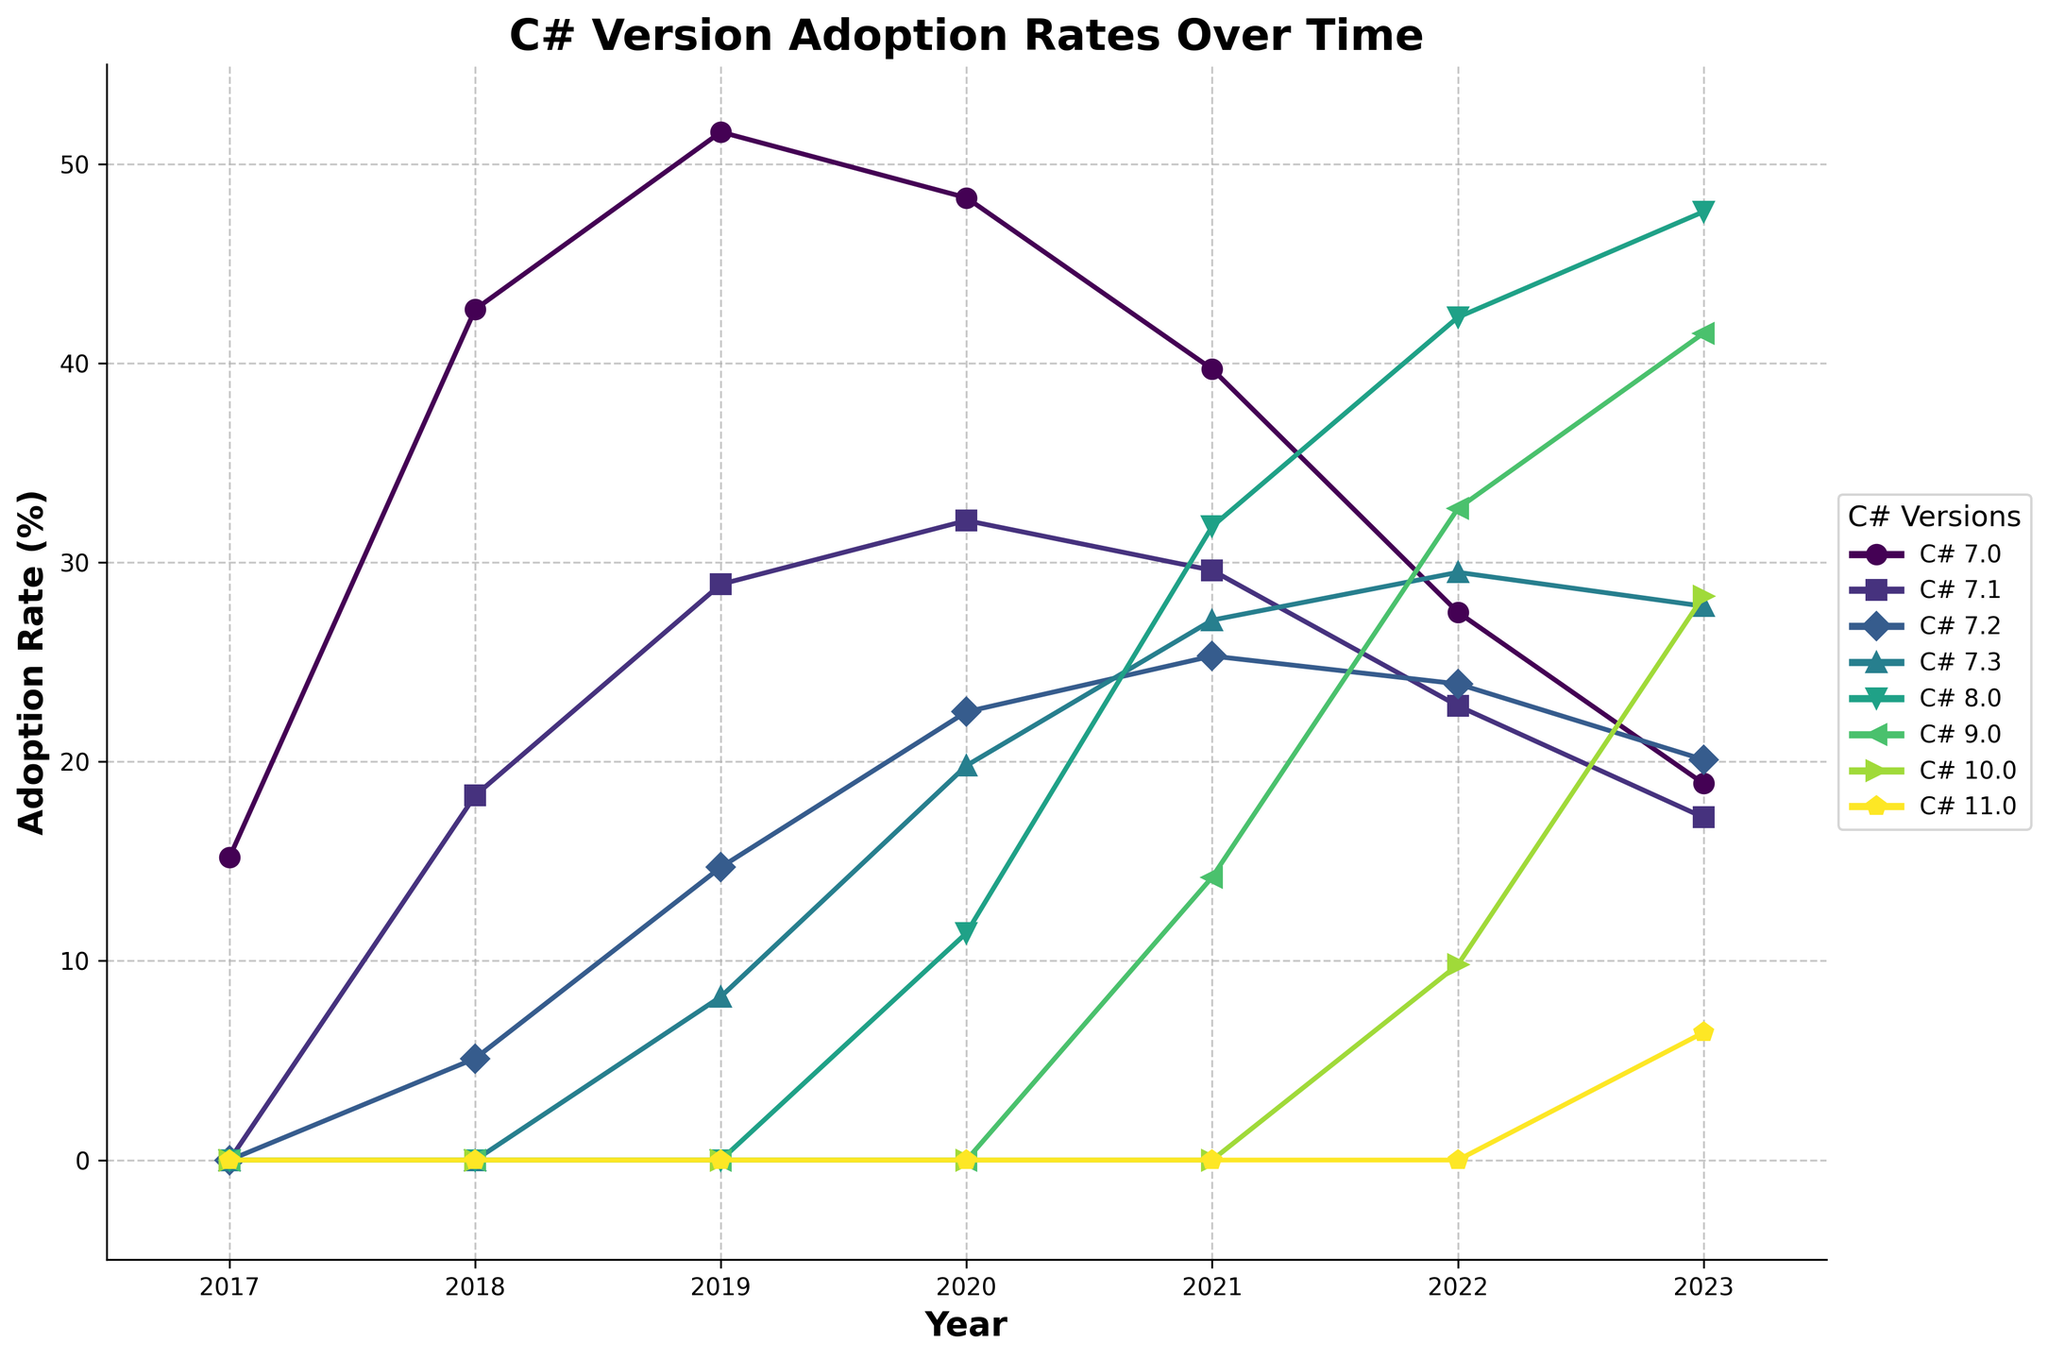Which year had the highest adoption rate for C# 7.0? From the figure, find the highest point on the line representing C# 7.0 and note the corresponding year on the x-axis.
Answer: 2019 In 2020, how much higher was the adoption rate of C# 7.3 compared to C# 8.0? Locate the values of C# 7.3 and C# 8.0 for the year 2020 on the figure. The adoption rate for C# 7.3 in 2020 was 19.8%, and for C# 8.0, it was 11.4%. Subtract the adoption rate of C# 8.0 from that of C# 7.3.
Answer: 8.4% Which C# version showed constant increase in adoption rate every year between 2020 and 2023? Examine the lines for each C# version between 2020 and 2023. Identify the one that showed an increasing trend each year.
Answer: C# 9.0 What was the adoption rate of C# 8.0 compared to C# 7.2 in 2021? Locate the points for C# 8.0 and C# 7.2 in 2021. C# 8.0 had an adoption rate of 31.8% and C# 7.2 had 25.3%. Compare the two values.
Answer: Higher Which year witnessed the introduction of the largest number of new C# versions? Review each year on the figure to see when new C# version lines first appear. The year with the most new version lines is the answer.
Answer: 2021 What is the summed adoption rate of all C# versions in 2023? Add the adoption rates of all the C# versions for the year 2023 from the figure: 18.9 + 17.2 + 20.1 + 27.8 + 47.6 + 41.5 + 28.3 + 6.4.
Answer: 207.8% Which C# version had a higher adoption rate in 2022, C# 9.0 or C# 10.0? Compare the points of C# 9.0 and C# 10.0 for 2022 on the figure. C# 9.0 had an adoption rate of 32.7% and C# 10.0 had 9.8%.
Answer: C# 9.0 In 2023, by how much did the adoption rate of C# 11.0 increase compared to 2022? Subtract the adoption rate of C# 11.0 in 2022 from its rate in 2023: 6.4% (2023) - 0% (2022).
Answer: 6.4% Which C# version had declining adoption rates from 2020 to 2023? Identify the lines that show a decreasing trend from 2020 to 2023 by checking if each year has a lower value than the previous one.
Answer: C# 7.0 